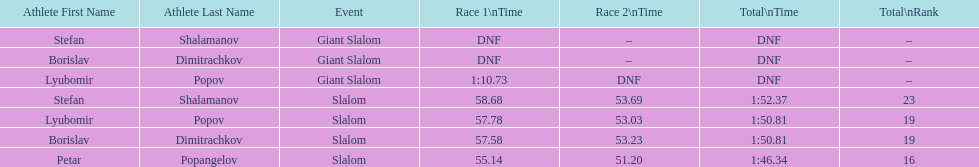Who came after borislav dimitrachkov and it's time for slalom Petar Popangelov. 